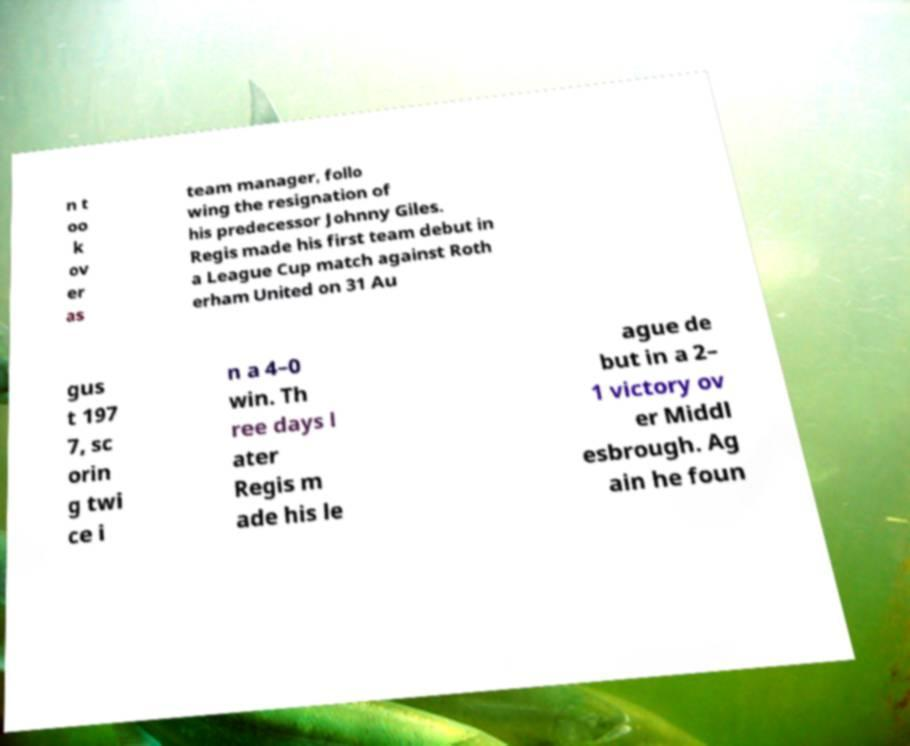What messages or text are displayed in this image? I need them in a readable, typed format. n t oo k ov er as team manager, follo wing the resignation of his predecessor Johnny Giles. Regis made his first team debut in a League Cup match against Roth erham United on 31 Au gus t 197 7, sc orin g twi ce i n a 4–0 win. Th ree days l ater Regis m ade his le ague de but in a 2– 1 victory ov er Middl esbrough. Ag ain he foun 